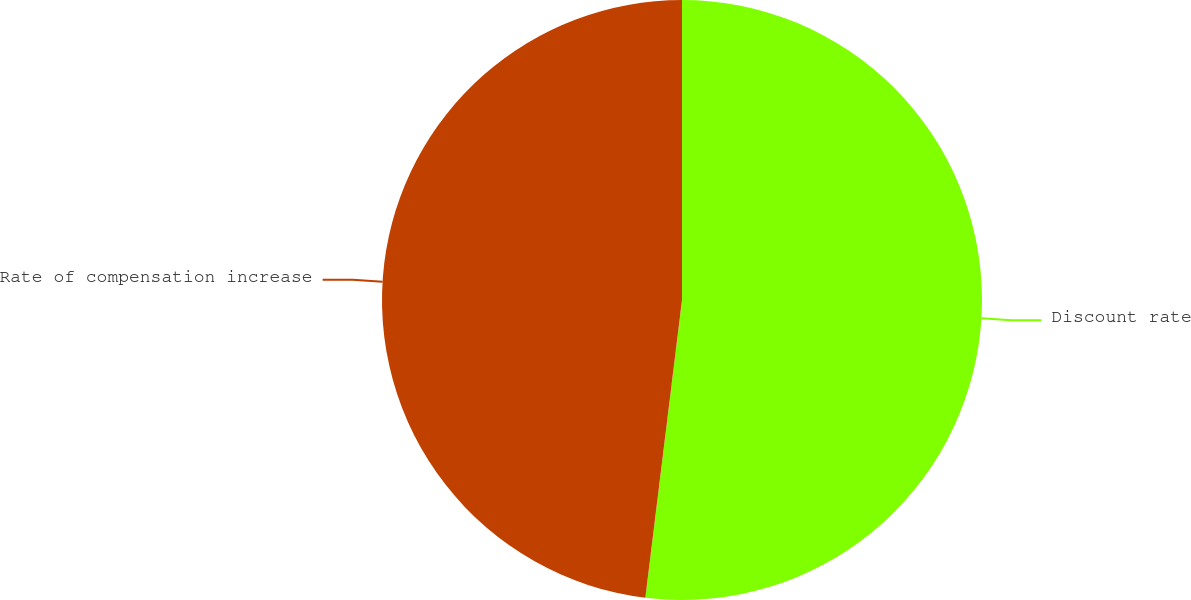Convert chart. <chart><loc_0><loc_0><loc_500><loc_500><pie_chart><fcel>Discount rate<fcel>Rate of compensation increase<nl><fcel>51.95%<fcel>48.05%<nl></chart> 